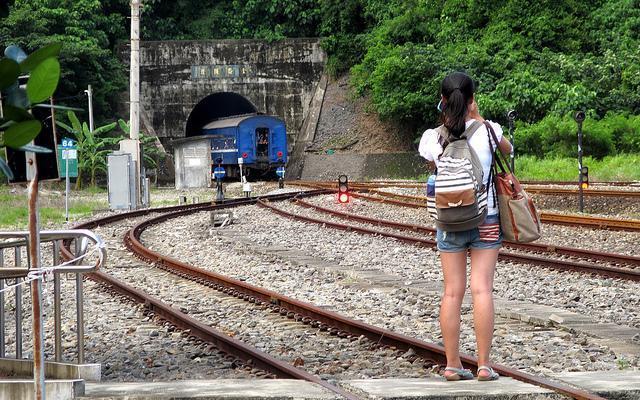What is the girl wearing?
Make your selection from the four choices given to correctly answer the question.
Options: Tiara, sandals, crown, armor. Sandals. 